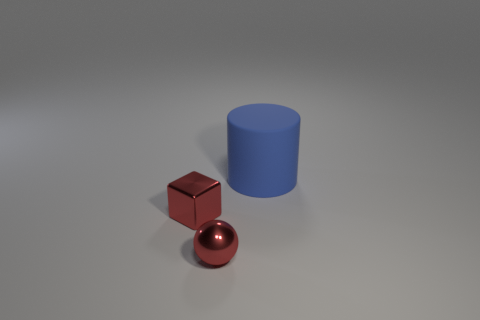How many other objects are the same color as the small metallic block?
Ensure brevity in your answer.  1. Do the small block and the thing that is to the right of the red metal ball have the same material?
Your answer should be compact. No. How many objects are both behind the metallic sphere and to the left of the big rubber cylinder?
Ensure brevity in your answer.  1. What color is the object behind the red shiny cube?
Keep it short and to the point. Blue. There is a tiny object that is in front of the red metal block; what number of things are behind it?
Offer a terse response. 2. There is a large thing; how many large blue rubber cylinders are left of it?
Your answer should be very brief. 0. What color is the small object that is behind the tiny red metal object that is in front of the tiny red thing that is to the left of the shiny sphere?
Give a very brief answer. Red. There is a tiny metallic object that is in front of the block; does it have the same color as the shiny object that is on the left side of the tiny sphere?
Offer a very short reply. Yes. There is a metallic object that is left of the small red thing on the right side of the red cube; what is its shape?
Your response must be concise. Cube. Is there a red object that has the same size as the metallic cube?
Offer a very short reply. Yes. 